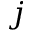Convert formula to latex. <formula><loc_0><loc_0><loc_500><loc_500>j</formula> 